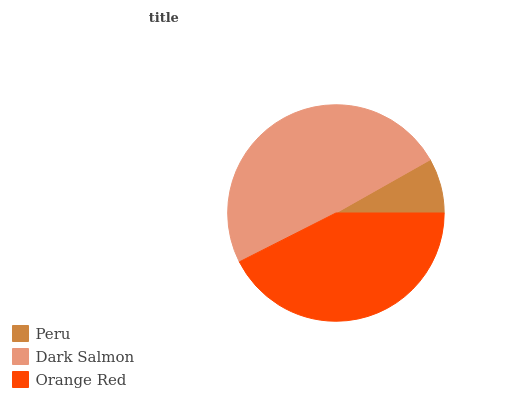Is Peru the minimum?
Answer yes or no. Yes. Is Dark Salmon the maximum?
Answer yes or no. Yes. Is Orange Red the minimum?
Answer yes or no. No. Is Orange Red the maximum?
Answer yes or no. No. Is Dark Salmon greater than Orange Red?
Answer yes or no. Yes. Is Orange Red less than Dark Salmon?
Answer yes or no. Yes. Is Orange Red greater than Dark Salmon?
Answer yes or no. No. Is Dark Salmon less than Orange Red?
Answer yes or no. No. Is Orange Red the high median?
Answer yes or no. Yes. Is Orange Red the low median?
Answer yes or no. Yes. Is Peru the high median?
Answer yes or no. No. Is Dark Salmon the low median?
Answer yes or no. No. 